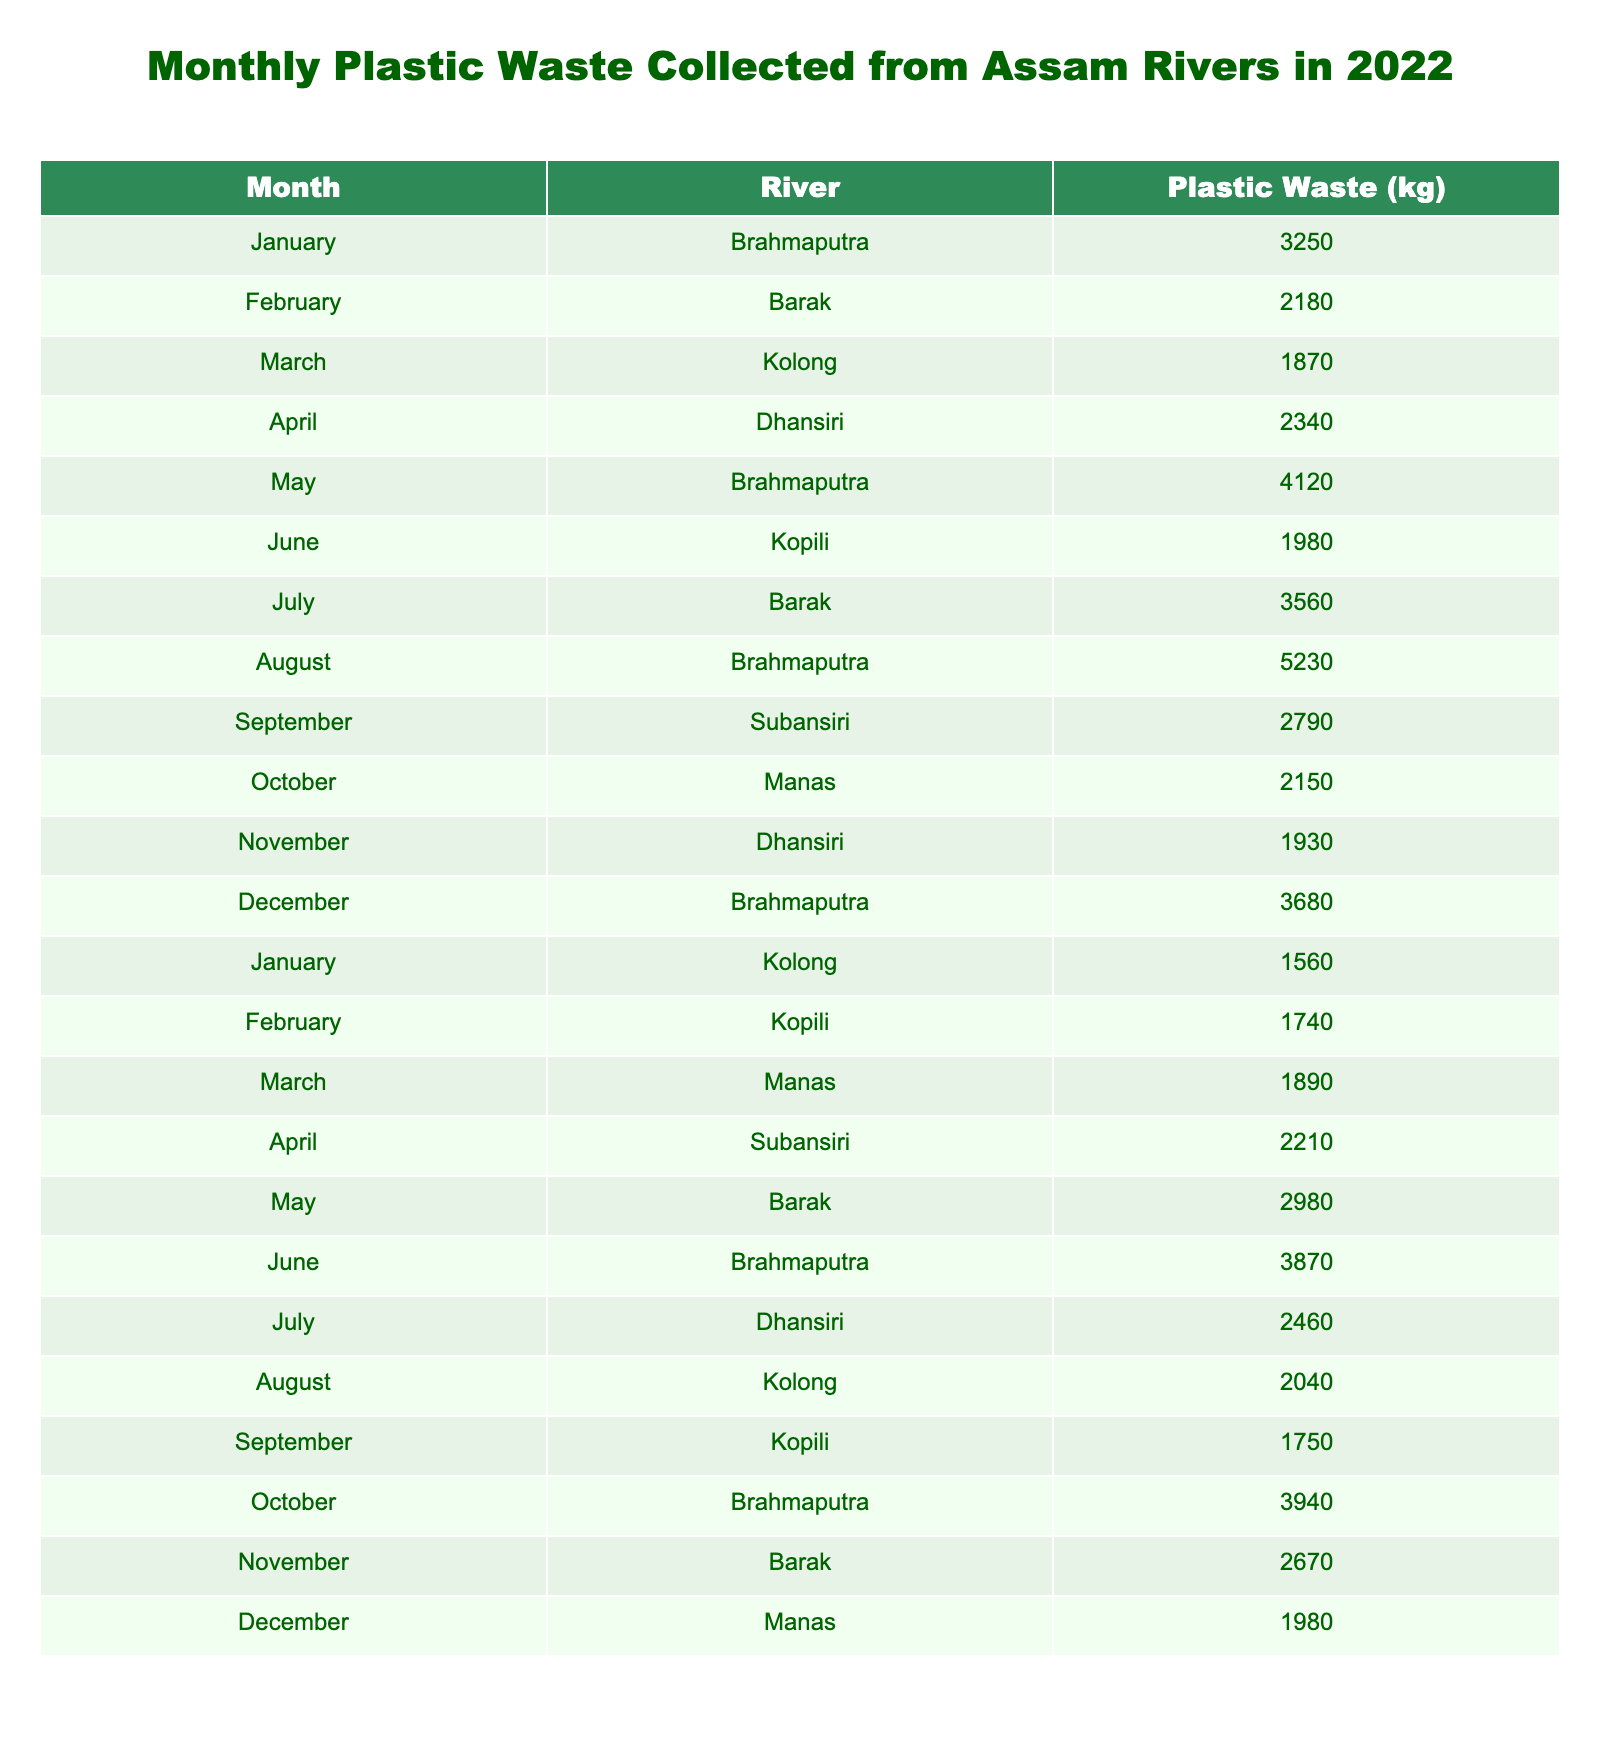What is the total plastic waste collected from the Brahmaputra River in 2022? The Brahmaputra River has data for January (3250 kg), May (4120 kg), August (5230 kg), June (3870 kg), October (3940 kg), and December (3680 kg). Adding these values: 3250 + 4120 + 5230 + 3870 + 3940 + 3680 = 22690 kg.
Answer: 22690 kg Which river had the highest amount of plastic waste collected in a single month? By checking the monthly data, the highest value is 5230 kg from the Brahmaputra River in August.
Answer: 5230 kg How much plastic waste was collected from Barak River in all months combined? The Barak River has data for February (2180 kg), July (3560 kg), May (2980 kg), and November (2670 kg). Adding these gives: 2180 + 3560 + 2980 + 2670 = 11390 kg.
Answer: 11390 kg Was there any month in which less plastic waste was collected than in January from the Dhansiri River? In January, Brahmaputra collected 3250 kg, while Dhansiri has values of 2340 kg in April and 1930 kg in November, both of which are less than January's amount.
Answer: Yes What is the average plastic waste collected from the Subansiri River? The Subansiri River has data for September (2790 kg) and April (2210 kg). To find the average: (2790 + 2210) / 2 = 2500 kg.
Answer: 2500 kg Did the Kopili River always have more than 2000 kg of plastic waste collected throughout the year? The Kopili River had values of 1980 kg in June, 1740 kg in February, and 1750 kg in September; both are below 2000 kg, indicating that it did not always exceed this amount.
Answer: No Which river had consistent increases in the amount of plastic waste collected from January to August? The Brahmaputra River shows the following amounts: 3250 kg in January, increases to 4120 kg in May, then to 5230 kg in August, indicating a consistent increase over those months.
Answer: Brahmaputra River What is the difference in plastic waste collected between the highest month and the lowest month overall? The highest monthly waste was 5230 kg (Brahmaputra in August) and the lowest was 1560 kg (Kolong in January). The difference is 5230 - 1560 = 3670 kg.
Answer: 3670 kg How many months collected over 3000 kg of plastic waste? The months with records over 3000 kg are January (Brahmaputra, 3250 kg), May (Brahmaputra, 4120 kg), August (Brahmaputra, 5230 kg), June (Brahmaputra, 3870 kg), October (Brahmaputra, 3940 kg), and July (Barak, 3560 kg). That totals six months.
Answer: 6 months Which river has the least total plastic waste collected over the year? Summing all collections, Kolong River collected 1870 kg (March), 1560 kg (January), and 2040 kg (August) totaling 4420 kg, which is the least compared to others.
Answer: Kolong River 